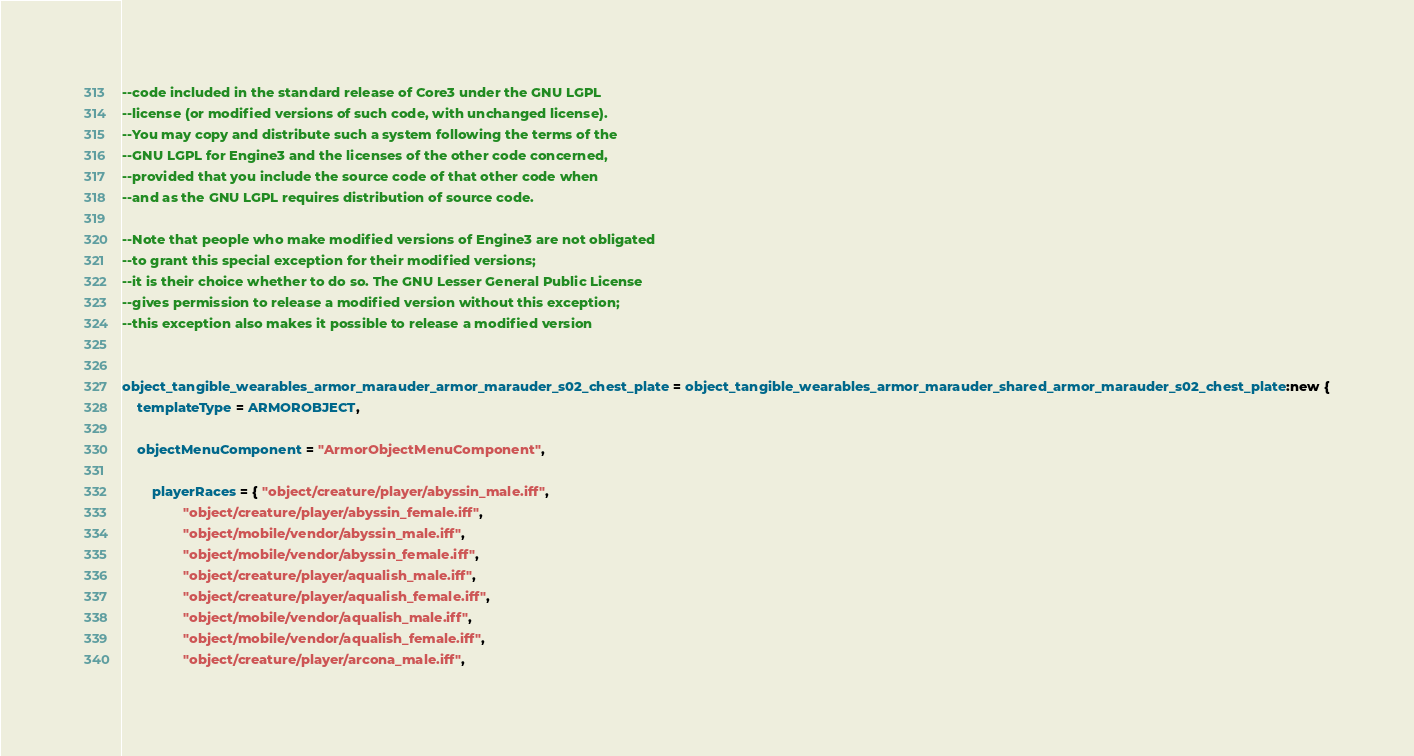<code> <loc_0><loc_0><loc_500><loc_500><_Lua_>--code included in the standard release of Core3 under the GNU LGPL 
--license (or modified versions of such code, with unchanged license). 
--You may copy and distribute such a system following the terms of the 
--GNU LGPL for Engine3 and the licenses of the other code concerned, 
--provided that you include the source code of that other code when 
--and as the GNU LGPL requires distribution of source code.

--Note that people who make modified versions of Engine3 are not obligated 
--to grant this special exception for their modified versions; 
--it is their choice whether to do so. The GNU Lesser General Public License 
--gives permission to release a modified version without this exception; 
--this exception also makes it possible to release a modified version 


object_tangible_wearables_armor_marauder_armor_marauder_s02_chest_plate = object_tangible_wearables_armor_marauder_shared_armor_marauder_s02_chest_plate:new {
	templateType = ARMOROBJECT,

	objectMenuComponent = "ArmorObjectMenuComponent",

		playerRaces = { "object/creature/player/abyssin_male.iff",
				"object/creature/player/abyssin_female.iff",
				"object/mobile/vendor/abyssin_male.iff",
				"object/mobile/vendor/abyssin_female.iff",
				"object/creature/player/aqualish_male.iff",
				"object/creature/player/aqualish_female.iff",
				"object/mobile/vendor/aqualish_male.iff",
				"object/mobile/vendor/aqualish_female.iff",
				"object/creature/player/arcona_male.iff",</code> 